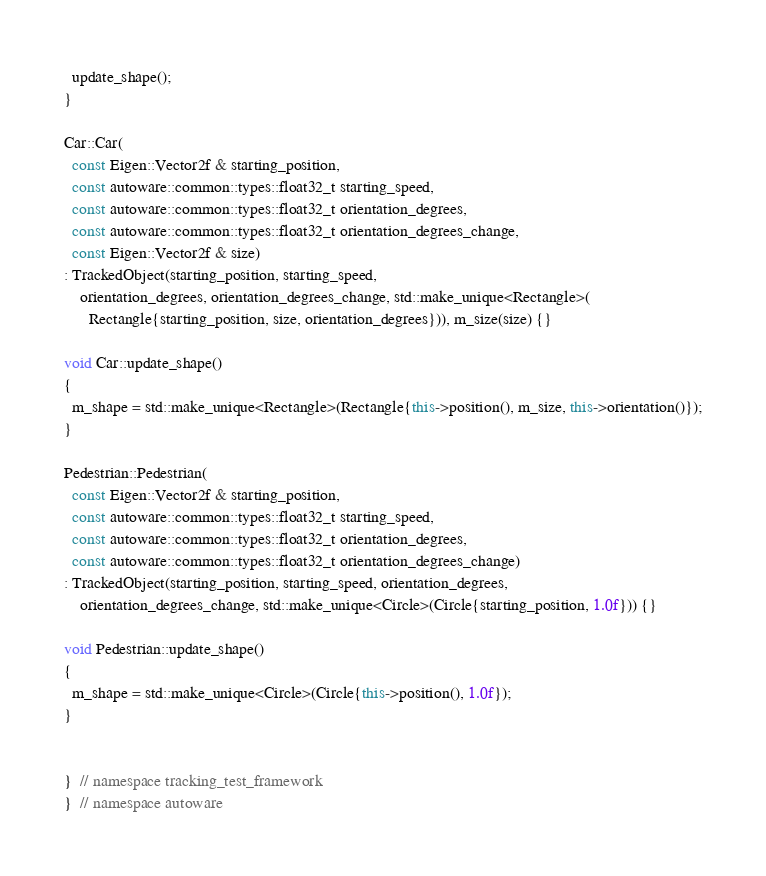Convert code to text. <code><loc_0><loc_0><loc_500><loc_500><_C++_>  update_shape();
}

Car::Car(
  const Eigen::Vector2f & starting_position,
  const autoware::common::types::float32_t starting_speed,
  const autoware::common::types::float32_t orientation_degrees,
  const autoware::common::types::float32_t orientation_degrees_change,
  const Eigen::Vector2f & size)
: TrackedObject(starting_position, starting_speed,
    orientation_degrees, orientation_degrees_change, std::make_unique<Rectangle>(
      Rectangle{starting_position, size, orientation_degrees})), m_size(size) {}

void Car::update_shape()
{
  m_shape = std::make_unique<Rectangle>(Rectangle{this->position(), m_size, this->orientation()});
}

Pedestrian::Pedestrian(
  const Eigen::Vector2f & starting_position,
  const autoware::common::types::float32_t starting_speed,
  const autoware::common::types::float32_t orientation_degrees,
  const autoware::common::types::float32_t orientation_degrees_change)
: TrackedObject(starting_position, starting_speed, orientation_degrees,
    orientation_degrees_change, std::make_unique<Circle>(Circle{starting_position, 1.0f})) {}

void Pedestrian::update_shape()
{
  m_shape = std::make_unique<Circle>(Circle{this->position(), 1.0f});
}


}  // namespace tracking_test_framework
}  // namespace autoware
</code> 